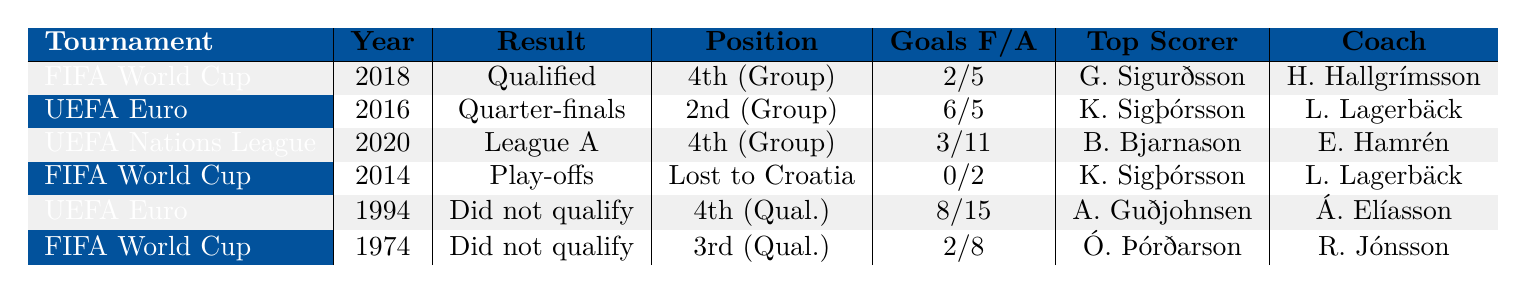What year did Iceland qualify for the UEFA European Championship? The table indicates that Iceland qualified for the UEFA European Championship in the year 2016, as mentioned in the performance data.
Answer: 2016 Who was Iceland's top scorer in the 2018 FIFA World Cup? According to the table, Gylfi Sigurðsson was the top scorer for Iceland during the 2018 FIFA World Cup.
Answer: Gylfi Sigurðsson How many goals did Iceland concede in the UEFA Nations League 2020? The table shows that Iceland conceded a total of 11 goals in the UEFA Nations League in 2020.
Answer: 11 Which tournament did Iceland not qualify for in 1994? The table specifies that Iceland did not qualify for the UEFA European Championship in 1994.
Answer: UEFA European Championship What was the aggregate score of Iceland's play-off match against Croatia in 2014 FIFA World Cup qualification? The performance data in the table reveals that Iceland's aggregate score against Croatia in the 2014 FIFA World Cup qualification play-offs was 0-2.
Answer: 0-2 In which tournament did Iceland reach the quarter-finals? The table indicates that Iceland reached the quarter-finals in the UEFA European Championship in 2016.
Answer: UEFA European Championship What is the difference in goals scored by Iceland between the 2016 UEFA European Championship and the 2020 UEFA Nations League? The table shows that Iceland scored 6 goals in the 2016 UEFA European Championship and 3 goals in the 2020 UEFA Nations League. The difference is 6 - 3 = 3.
Answer: 3 How many tournaments did Iceland participate in from 1974 to 2020? The table lists six participations: 1974 FIFA World Cup, 1994 UEFA European Championship, 2014 FIFA World Cup, 2016 UEFA European Championship, 2018 FIFA World Cup, and 2020 UEFA Nations League. Therefore, the total is 6.
Answer: 6 Did Iceland score more goals in the 2016 UEFA European Championship than they conceded? In the table, Iceland scored 6 goals and conceded 5 goals in the 2016 UEFA European Championship, which means they scored more than they conceded (6 > 5).
Answer: Yes What was the coaching difference between Iceland's performance in 2016 UEFA European Championship and 2020 UEFA Nations League? The table indicates that Iceland was coached by Lars Lagerbäck in the 2016 UEFA European Championship and Erik Hamrén in the 2020 UEFA Nations League, showing a change in coaches between these tournaments.
Answer: Change in coaches 